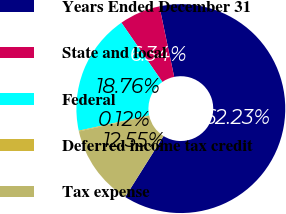<chart> <loc_0><loc_0><loc_500><loc_500><pie_chart><fcel>Years Ended December 31<fcel>State and local<fcel>Federal<fcel>Deferred income tax credit<fcel>Tax expense<nl><fcel>62.24%<fcel>6.34%<fcel>18.76%<fcel>0.12%<fcel>12.55%<nl></chart> 